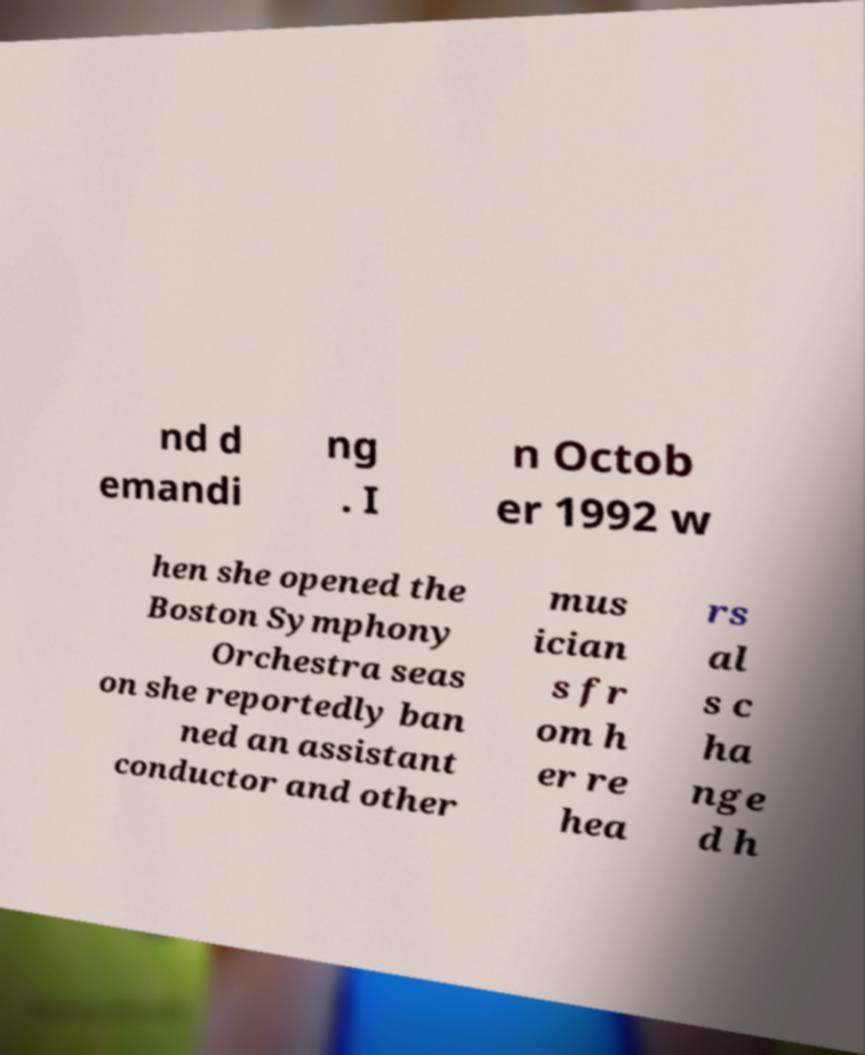I need the written content from this picture converted into text. Can you do that? nd d emandi ng . I n Octob er 1992 w hen she opened the Boston Symphony Orchestra seas on she reportedly ban ned an assistant conductor and other mus ician s fr om h er re hea rs al s c ha nge d h 